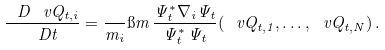<formula> <loc_0><loc_0><loc_500><loc_500>\frac { \ D \ v Q _ { t , i } } { \ D t } = \frac { } { m _ { i } } \i m \, \frac { \Psi ^ { * } _ { t } \nabla _ { i } \Psi _ { t } } { \Psi ^ { * } _ { t } \, \Psi _ { t } } ( \ v Q _ { t , 1 } , \dots , \ v Q _ { t , N } ) \, .</formula> 